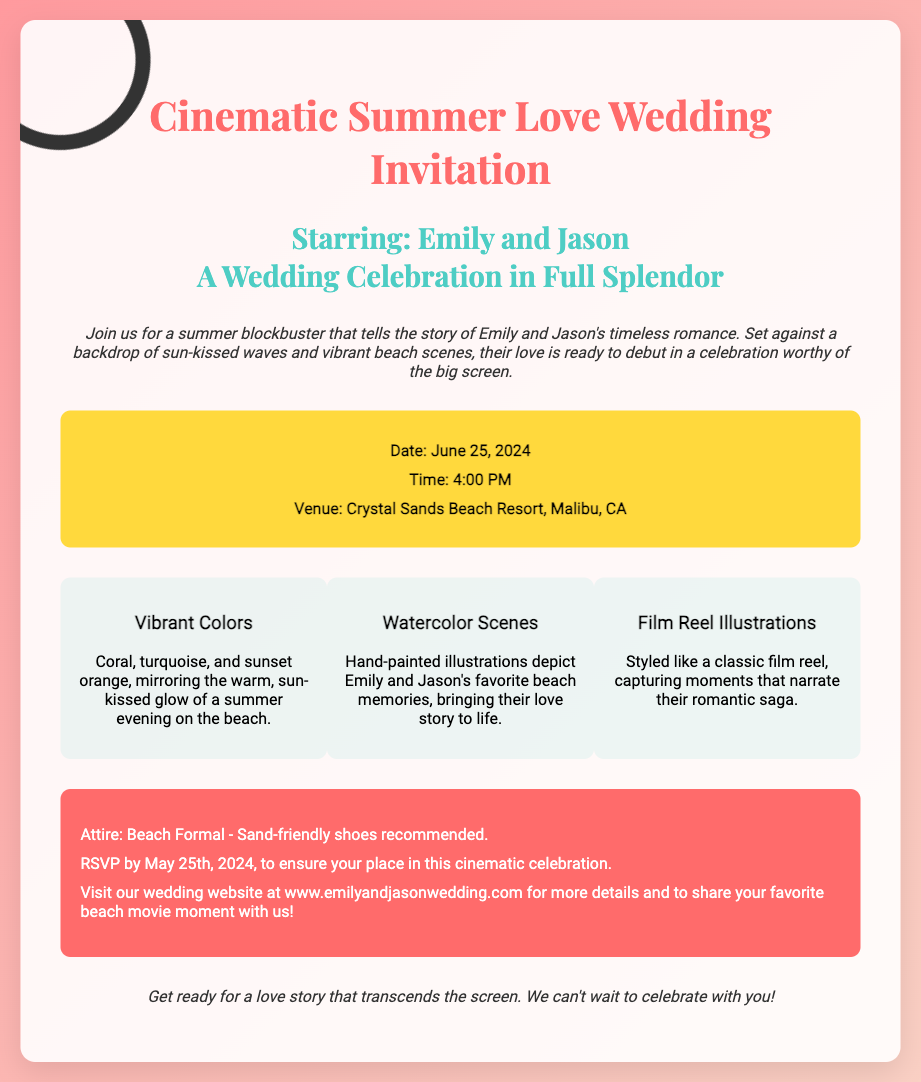What is the date of the wedding? The date of the wedding is specifically stated in the details section of the invitation.
Answer: June 25, 2024 What time does the wedding start? The start time of the wedding is highlighted in the details section.
Answer: 4:00 PM Where is the wedding venue? The venue for the wedding is mentioned in the details section of the invitation.
Answer: Crystal Sands Beach Resort, Malibu, CA What is the attire suggested for guests? The attire information is found in the special notes section of the invitation.
Answer: Beach Formal What is the last date to RSVP? The RSVP deadline is clearly stated in the special notes section.
Answer: May 25th, 2024 What colors are mentioned in the invitation? The colors are listed in the creative elements section of the invitation.
Answer: Coral, turquoise, and sunset orange What theme does the invitation suggest? The overall theme of the wedding is described in the introductory text of the invitation.
Answer: Cinematic Summer Love What kind of scenes are illustrated in the invitation? The type of scenes is specified in the creative elements section as part of the wedding theme.
Answer: Watercolor Scenes What is the wedding website URL? The URL of the wedding website is included in the special notes section for details.
Answer: www.emilyandjasonwedding.com 